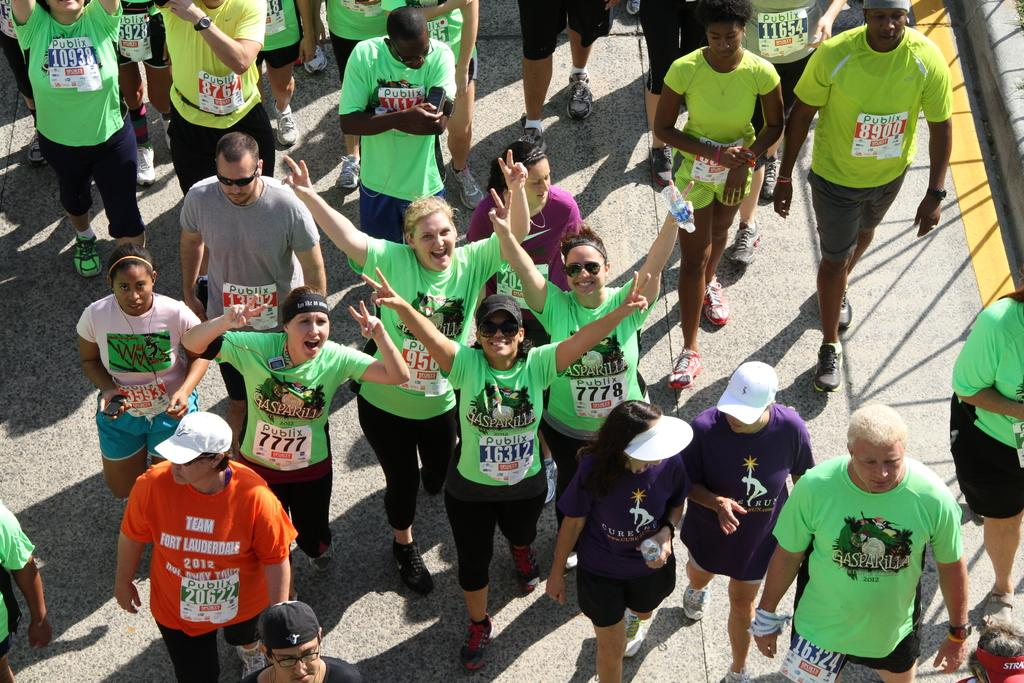How many people are in the image? There is a group of people in the image, but the exact number is not specified. What are the people doing in the image? The people are standing on a road. What type of pies are being sold on the road in the image? There is no mention of pies or any sales activity in the image. How much income do the people in the image earn per hour? There is no information about the people's income in the image. 